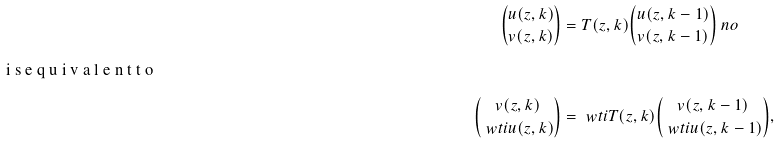Convert formula to latex. <formula><loc_0><loc_0><loc_500><loc_500>\binom { u ( z , k ) } { v ( z , k ) } & = T ( z , k ) \binom { u ( z , k - 1 ) } { v ( z , k - 1 ) } \ n o \\ \intertext { i s e q u i v a l e n t t o } \binom { v ( z , k ) } { \ w t i u ( z , k ) } & = \ w t i T ( z , k ) \binom { v ( z , k - 1 ) } { \ w t i u ( z , k - 1 ) } ,</formula> 